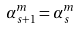Convert formula to latex. <formula><loc_0><loc_0><loc_500><loc_500>\alpha _ { s + 1 } ^ { m } = \alpha _ { s } ^ { m }</formula> 